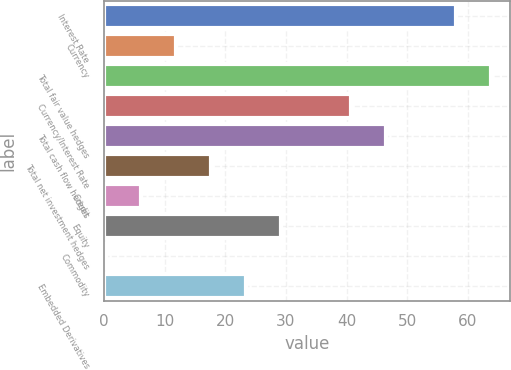Convert chart to OTSL. <chart><loc_0><loc_0><loc_500><loc_500><bar_chart><fcel>Interest Rate<fcel>Currency<fcel>Total fair value hedges<fcel>Currency/Interest Rate<fcel>Total cash flow hedges<fcel>Total net investment hedges<fcel>Credit<fcel>Equity<fcel>Commodity<fcel>Embedded Derivatives<nl><fcel>58.02<fcel>11.89<fcel>63.79<fcel>40.73<fcel>46.49<fcel>17.66<fcel>6.12<fcel>29.2<fcel>0.35<fcel>23.43<nl></chart> 